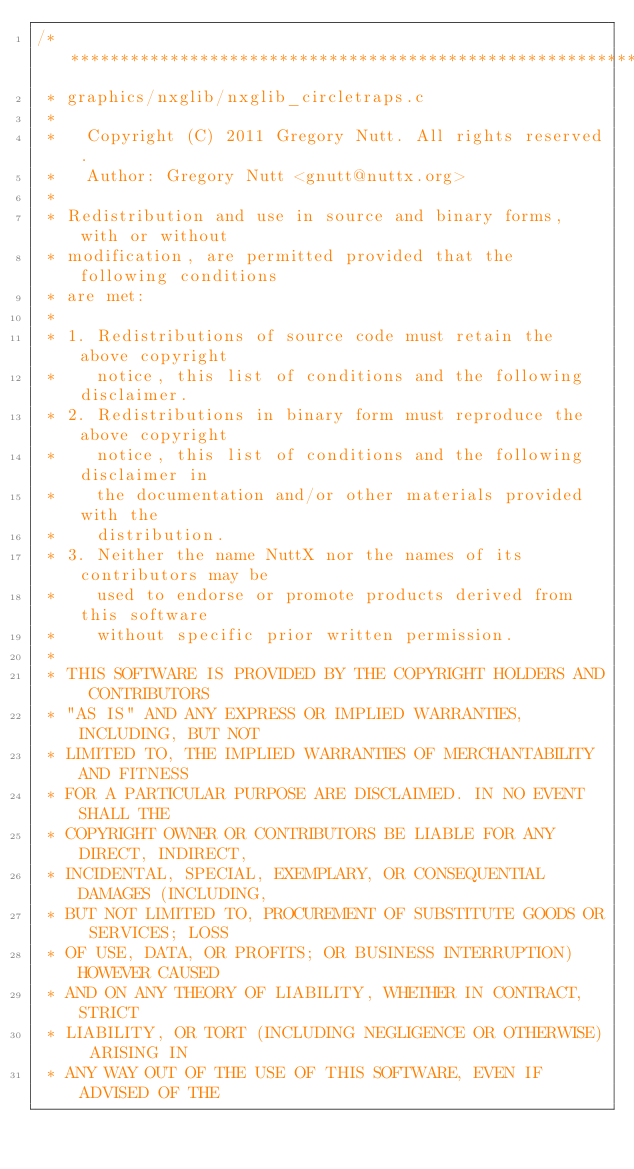Convert code to text. <code><loc_0><loc_0><loc_500><loc_500><_C_>/****************************************************************************
 * graphics/nxglib/nxglib_circletraps.c
 *
 *   Copyright (C) 2011 Gregory Nutt. All rights reserved.
 *   Author: Gregory Nutt <gnutt@nuttx.org>
 *
 * Redistribution and use in source and binary forms, with or without
 * modification, are permitted provided that the following conditions
 * are met:
 *
 * 1. Redistributions of source code must retain the above copyright
 *    notice, this list of conditions and the following disclaimer.
 * 2. Redistributions in binary form must reproduce the above copyright
 *    notice, this list of conditions and the following disclaimer in
 *    the documentation and/or other materials provided with the
 *    distribution.
 * 3. Neither the name NuttX nor the names of its contributors may be
 *    used to endorse or promote products derived from this software
 *    without specific prior written permission.
 *
 * THIS SOFTWARE IS PROVIDED BY THE COPYRIGHT HOLDERS AND CONTRIBUTORS
 * "AS IS" AND ANY EXPRESS OR IMPLIED WARRANTIES, INCLUDING, BUT NOT
 * LIMITED TO, THE IMPLIED WARRANTIES OF MERCHANTABILITY AND FITNESS
 * FOR A PARTICULAR PURPOSE ARE DISCLAIMED. IN NO EVENT SHALL THE
 * COPYRIGHT OWNER OR CONTRIBUTORS BE LIABLE FOR ANY DIRECT, INDIRECT,
 * INCIDENTAL, SPECIAL, EXEMPLARY, OR CONSEQUENTIAL DAMAGES (INCLUDING,
 * BUT NOT LIMITED TO, PROCUREMENT OF SUBSTITUTE GOODS OR SERVICES; LOSS
 * OF USE, DATA, OR PROFITS; OR BUSINESS INTERRUPTION) HOWEVER CAUSED
 * AND ON ANY THEORY OF LIABILITY, WHETHER IN CONTRACT, STRICT
 * LIABILITY, OR TORT (INCLUDING NEGLIGENCE OR OTHERWISE) ARISING IN
 * ANY WAY OUT OF THE USE OF THIS SOFTWARE, EVEN IF ADVISED OF THE</code> 